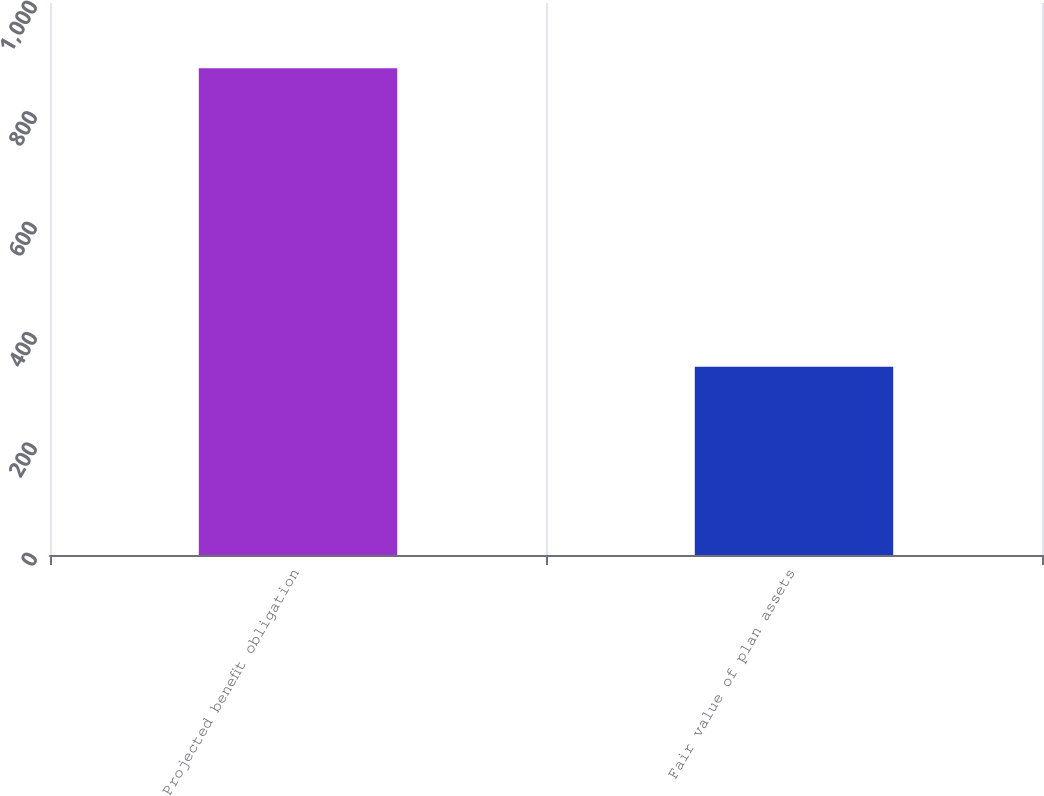<chart> <loc_0><loc_0><loc_500><loc_500><bar_chart><fcel>Projected benefit obligation<fcel>Fair value of plan assets<nl><fcel>882<fcel>341<nl></chart> 